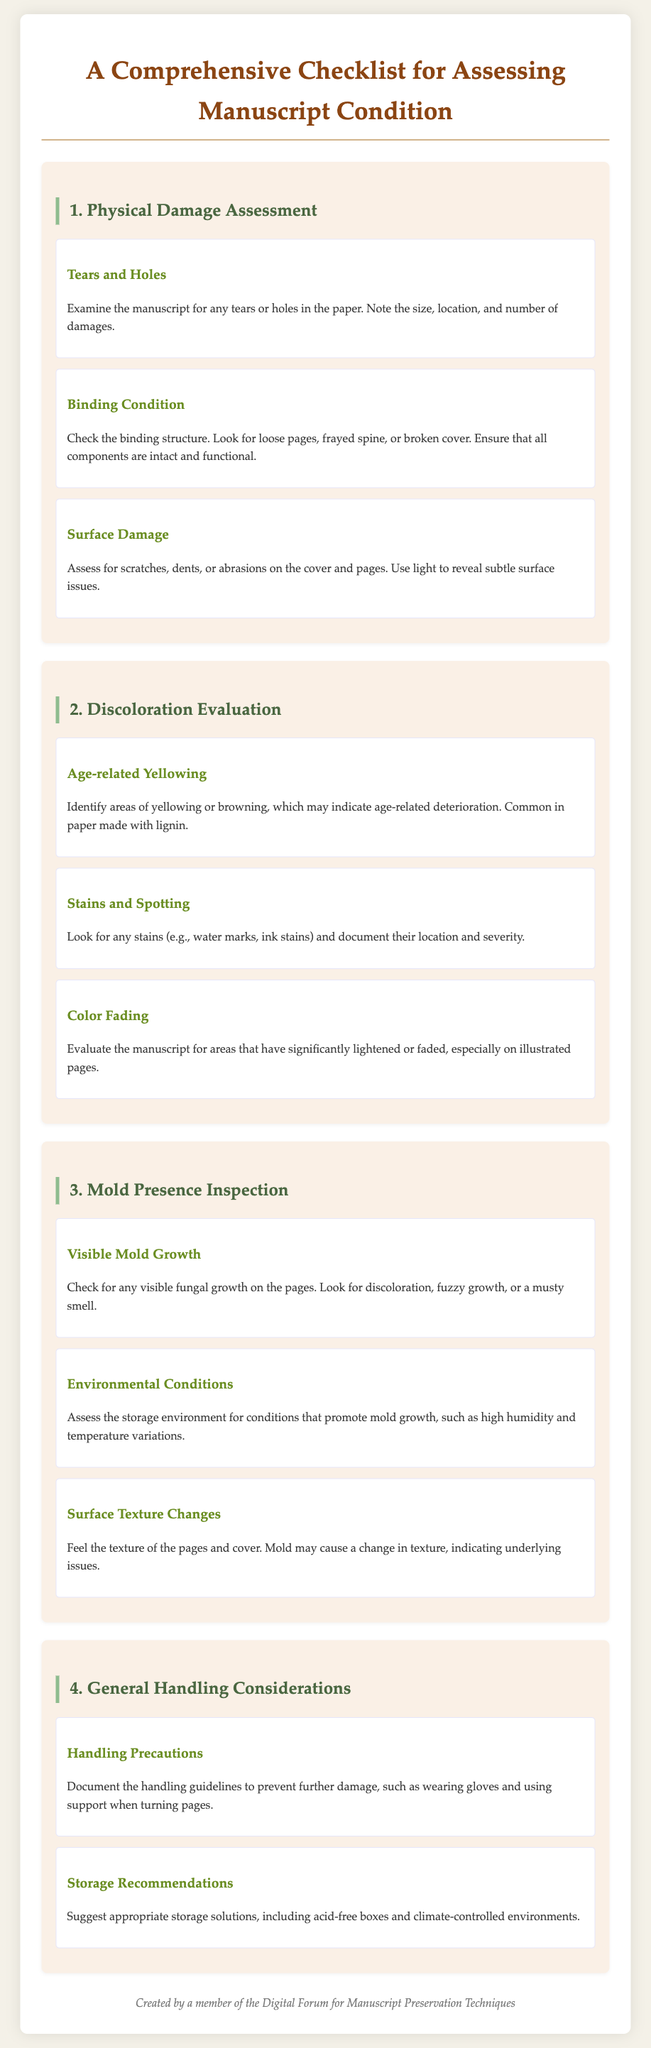What is the title of the checklist? The title is explicitly stated at the beginning of the document.
Answer: A Comprehensive Checklist for Assessing Manuscript Condition What is one type of physical damage assessed? The document lists specific types of physical damage under the Physical Damage Assessment section.
Answer: Tears and Holes What should be examined to assess the binding condition? The checklist specifies what to look for when checking the binding structure of the manuscript.
Answer: Loose pages, frayed spine, or broken cover What type of discoloration is commonly seen in aged manuscripts? The document mentions a specific type of discoloration related to age in the Discoloration Evaluation section.
Answer: Age-related Yellowing What indicates a potential mold issue on the manuscript? A specific characteristic of mold growth is highlighted in the Mold Presence Inspection section.
Answer: Visible fungal growth What handling recommendation is provided? The document includes suggestions under General Handling Considerations to prevent further damage.
Answer: Wearing gloves What are recommended storage solutions? The checklist provides specific solutions for storing manuscripts properly in the General Handling Considerations section.
Answer: Acid-free boxes and climate-controlled environments What should be assessed in the storage environment? The document highlights an aspect of the storage environment related to mold growth.
Answer: Conditions that promote mold growth What is the predominant color of the headings? A specific color is referenced in the visual design elements of the document.
Answer: Green 